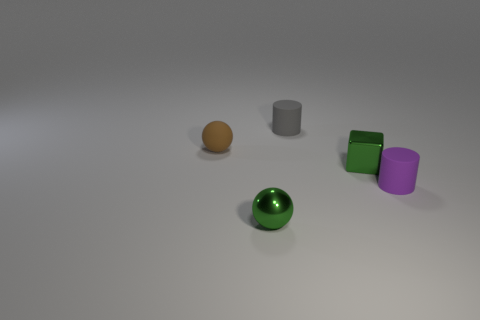What number of large objects are green shiny blocks or cyan balls?
Your answer should be compact. 0. Are there an equal number of small matte balls that are behind the tiny rubber ball and tiny brown balls?
Provide a short and direct response. No. Is there a metallic block that is behind the green metallic object behind the tiny green ball?
Provide a short and direct response. No. What number of other objects are there of the same color as the matte sphere?
Provide a succinct answer. 0. The small metallic ball is what color?
Give a very brief answer. Green. How big is the thing that is to the right of the metal ball and on the left side of the shiny cube?
Offer a very short reply. Small. How many objects are either objects behind the tiny green block or small things?
Your response must be concise. 5. The small green object that is made of the same material as the small green block is what shape?
Provide a short and direct response. Sphere. The tiny gray object is what shape?
Give a very brief answer. Cylinder. What color is the object that is both to the left of the gray matte object and in front of the green cube?
Offer a terse response. Green. 